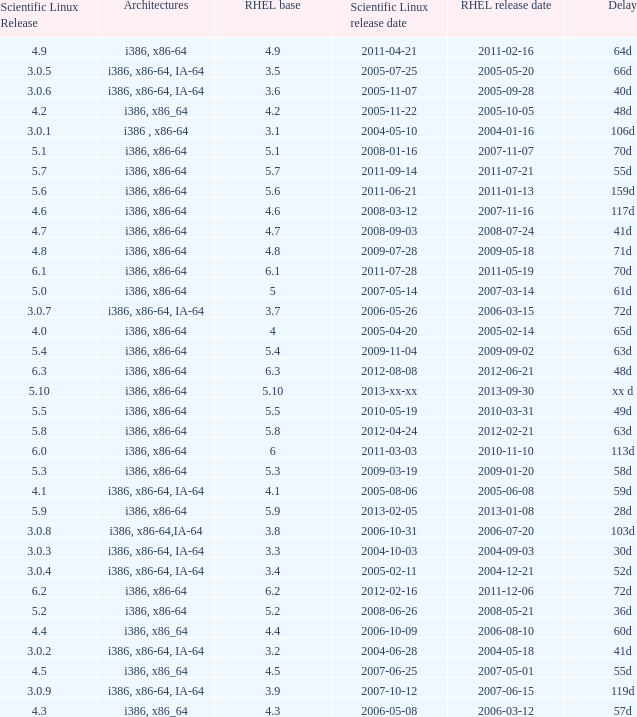Name the scientific linux release when delay is 28d 5.9. 